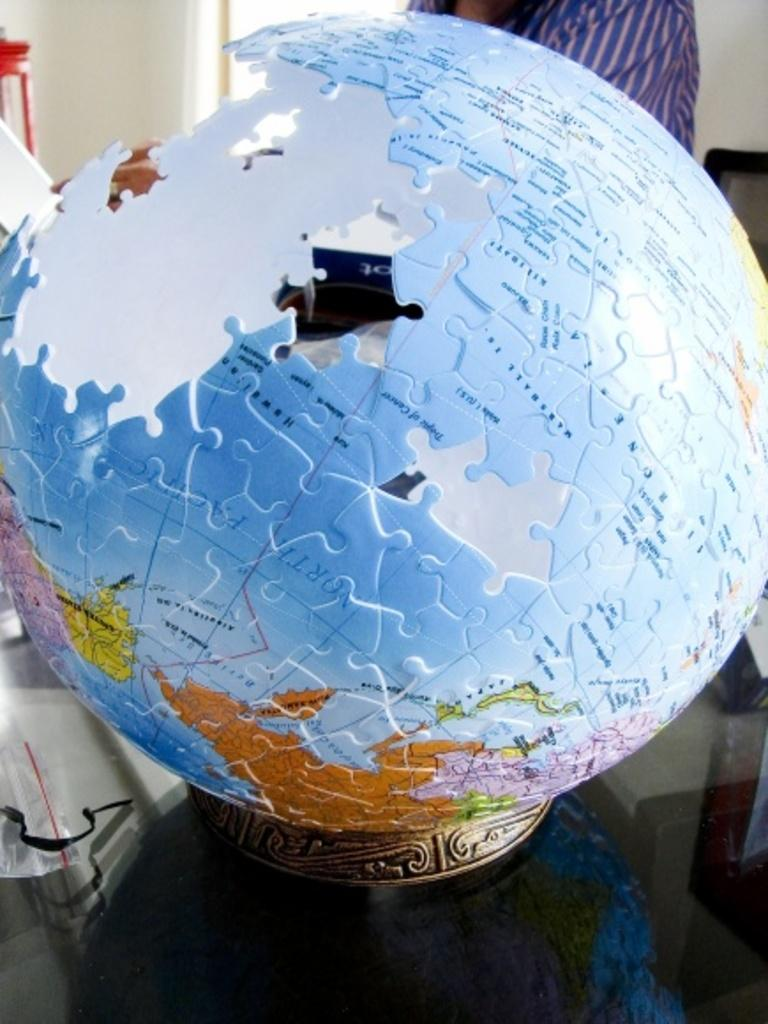What object in the image represents the Earth? There is a globe in the image, which represents the Earth. What other subject can be seen in the image? There is a person in the image. What is visible in the background of the image? There is a wall in the background of the image. What type of elbow can be seen in the image? There is no elbow present in the image. What unit of measurement is used to determine the size of the globe in the image? The facts provided do not mention any specific unit of measurement for the globe. How many arrows are visible in the quiver in the image? There is no quiver or arrows present in the image. 